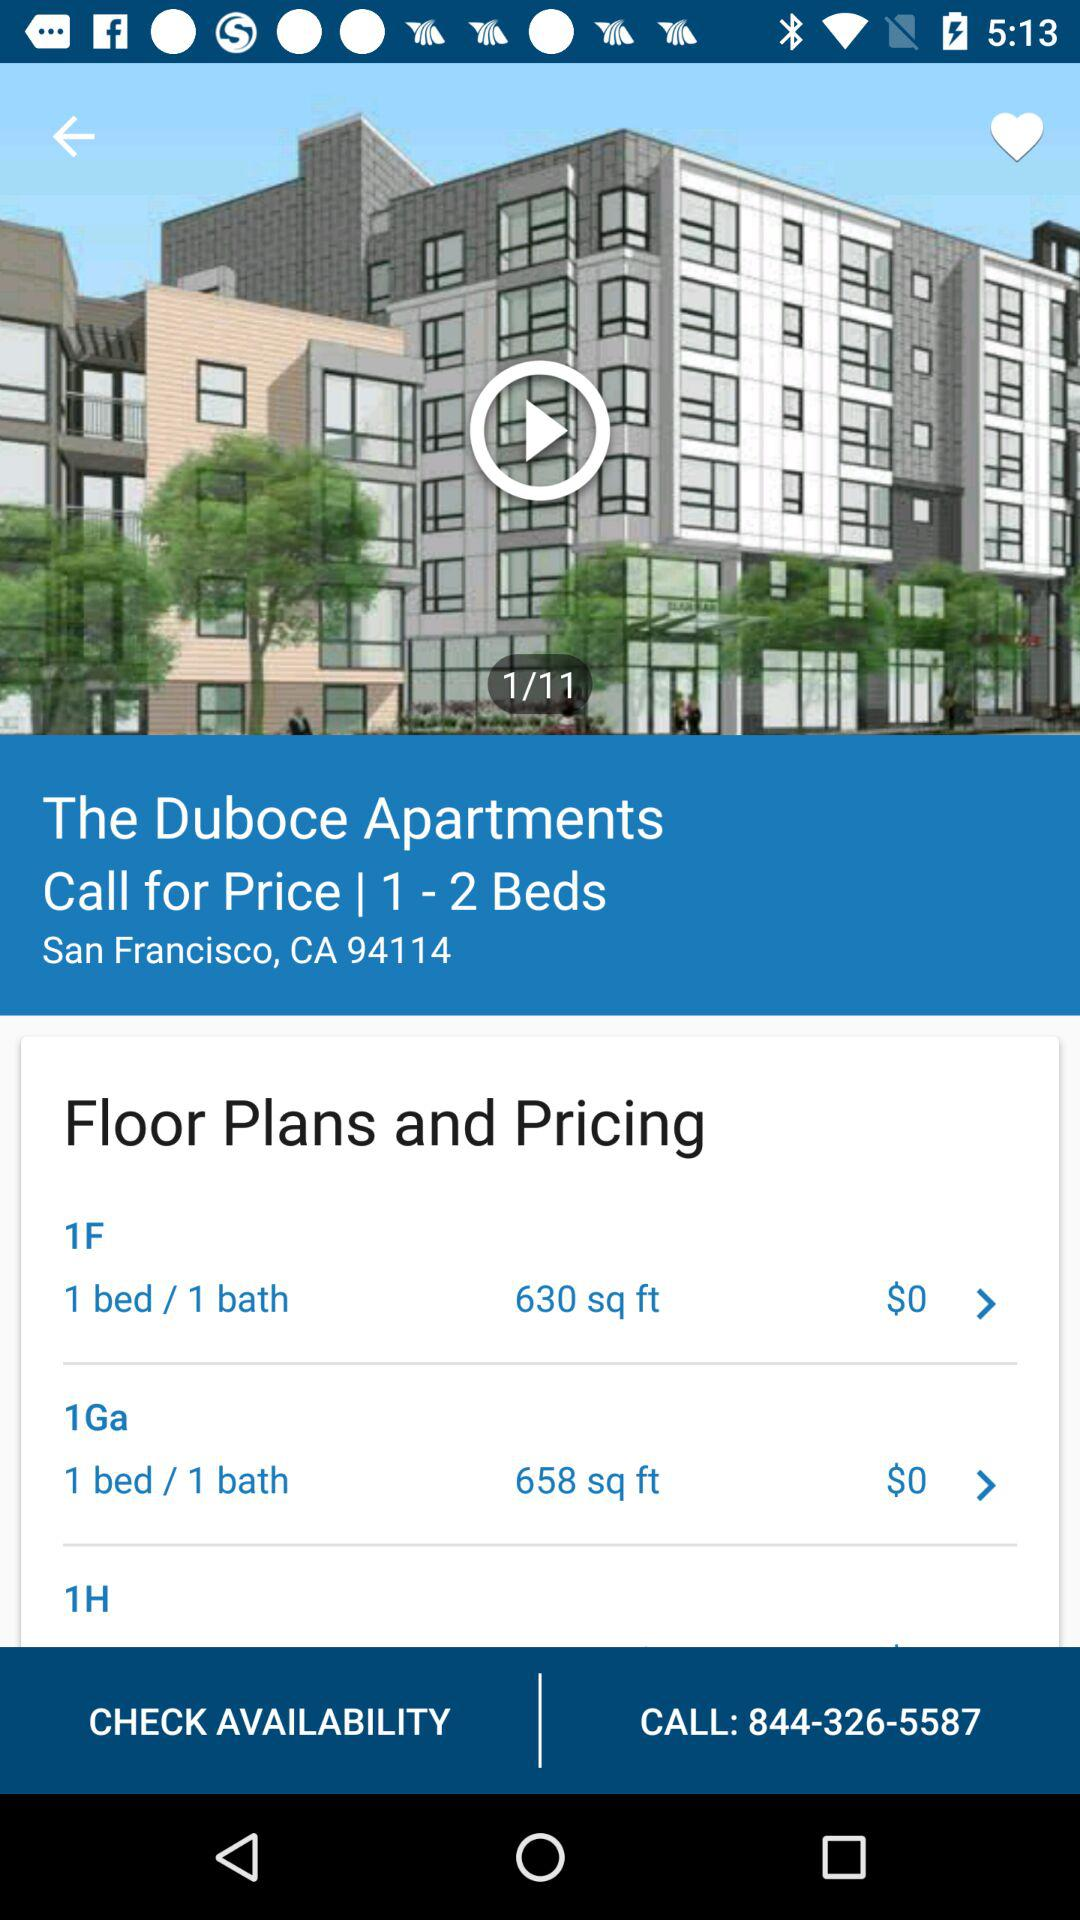How many more square feet is the 1Ga floor plan than the 1F floor plan?
Answer the question using a single word or phrase. 28 